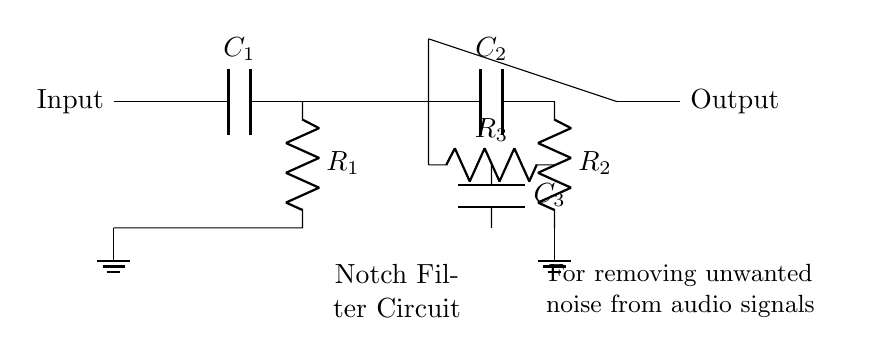What components are used in the circuit? The circuit includes a capacitor, three resistors, and an operational amplifier, indicated by the labels in the diagram.
Answer: capacitor, three resistors, operational amplifier What is the function of the op-amp in this circuit? The operational amplifier amplifies the difference between its input signals. It helps in filtering unwanted noise by providing gain where necessary in a notch filter configuration.
Answer: amplification What value does R1 represent in the circuit? R1 is a resistor positioned in the high-pass filter section of the circuit that works with capacitor C1 to determine the cutoff frequency for the higher frequencies to pass through.
Answer: R1 What type of filter is depicted in the diagram? The circuit is a notch filter, specifically designed to remove unwanted frequencies (noise) while allowing others to pass.
Answer: notch filter How many capacitors are present in this circuit? There are three capacitors present, labeled C1, C2, and C3 across different sections of the circuit.
Answer: three What is the role of C2 in the circuit? C2 is part of the twin-T network in the circuit that helps achieve the notch filtering effect by combining with resistors to create a specific frequency response.
Answer: notch filtering What is the output of the circuit connected to? The output of the circuit is connected to the terminal labeled Output, indicating where the filtered audio signal will be sent.
Answer: Output 